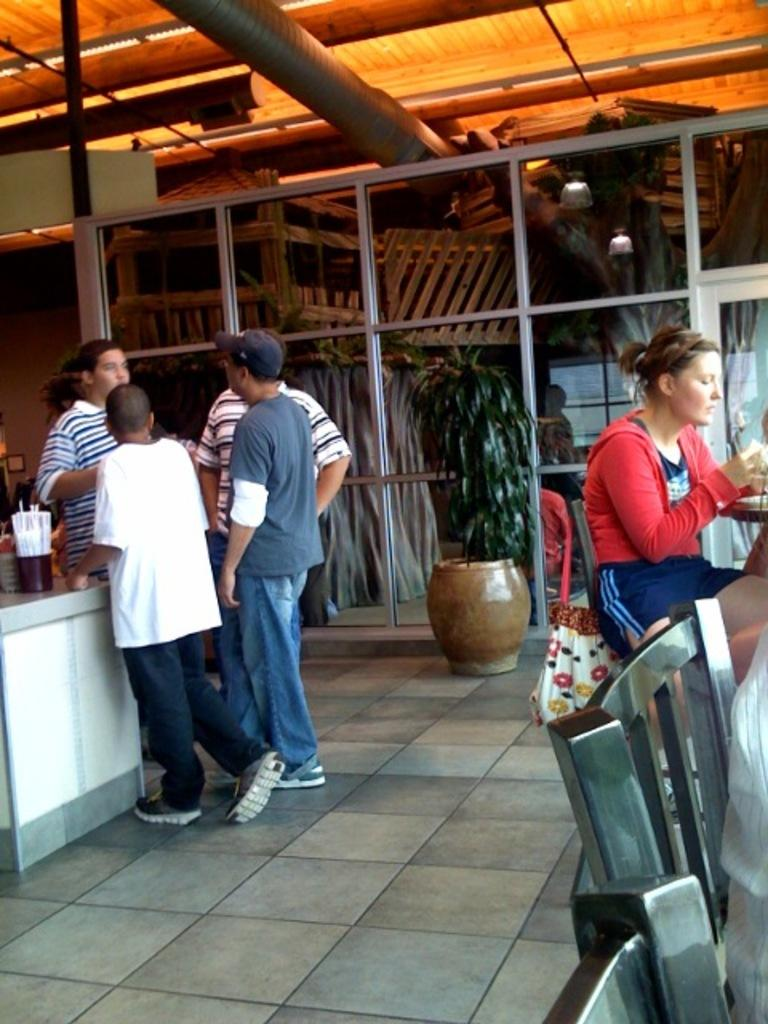What is happening on the left side of the image? There are people standing on the left side of the image. What is the woman doing on the right side of the image? There is a woman sitting on a chair on the right side of the image. Can you describe any furniture or objects in the image? Yes, there is a table in the image. Can you see a kitty playing with a cherry on the table in the image? There is no kitty or cherry present on the table in the image. 